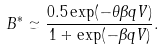<formula> <loc_0><loc_0><loc_500><loc_500>B ^ { * } \simeq \frac { 0 . 5 \exp ( - \theta \beta q V ) } { 1 + \exp ( - \beta q V ) } .</formula> 